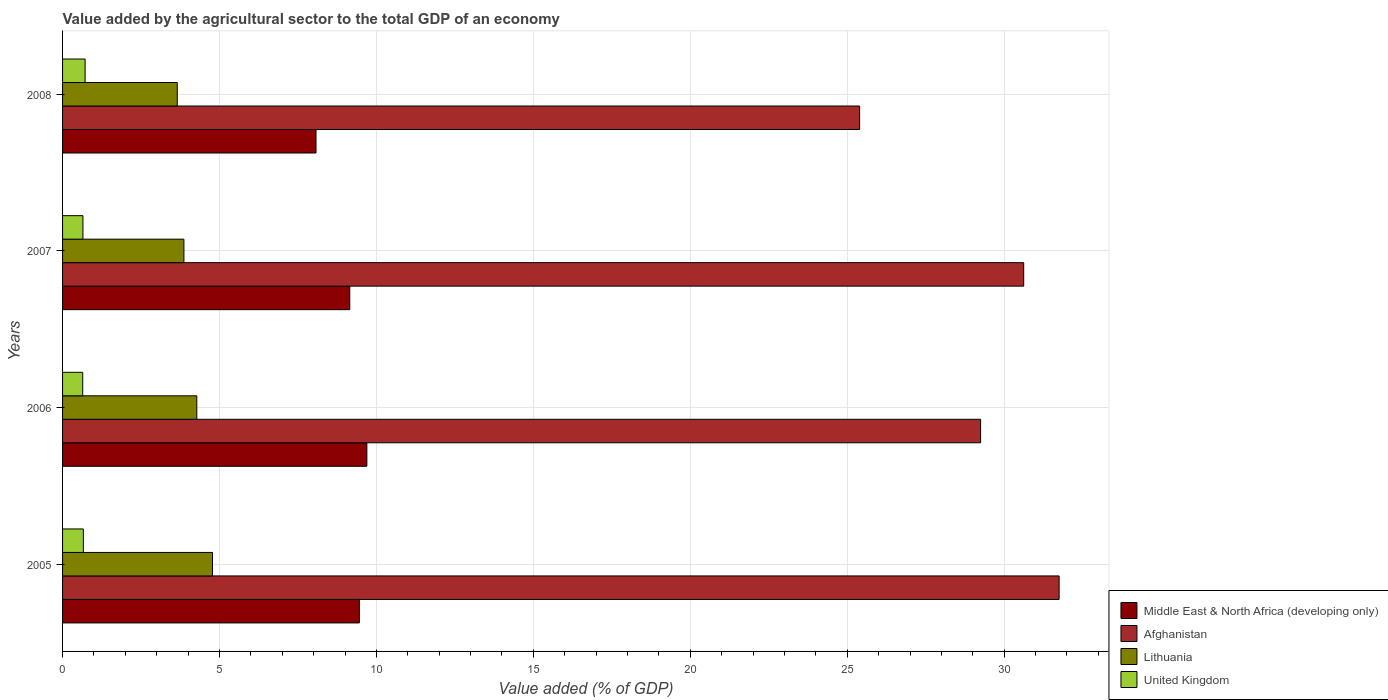How many different coloured bars are there?
Your response must be concise. 4. Are the number of bars on each tick of the Y-axis equal?
Keep it short and to the point. Yes. How many bars are there on the 4th tick from the top?
Give a very brief answer. 4. How many bars are there on the 1st tick from the bottom?
Your answer should be compact. 4. In how many cases, is the number of bars for a given year not equal to the number of legend labels?
Your answer should be very brief. 0. What is the value added by the agricultural sector to the total GDP in United Kingdom in 2005?
Your answer should be compact. 0.66. Across all years, what is the maximum value added by the agricultural sector to the total GDP in Lithuania?
Provide a succinct answer. 4.78. Across all years, what is the minimum value added by the agricultural sector to the total GDP in Lithuania?
Provide a succinct answer. 3.65. In which year was the value added by the agricultural sector to the total GDP in Middle East & North Africa (developing only) minimum?
Keep it short and to the point. 2008. What is the total value added by the agricultural sector to the total GDP in Afghanistan in the graph?
Your response must be concise. 117.02. What is the difference between the value added by the agricultural sector to the total GDP in Lithuania in 2005 and that in 2008?
Ensure brevity in your answer.  1.12. What is the difference between the value added by the agricultural sector to the total GDP in United Kingdom in 2006 and the value added by the agricultural sector to the total GDP in Afghanistan in 2005?
Keep it short and to the point. -31.11. What is the average value added by the agricultural sector to the total GDP in United Kingdom per year?
Provide a short and direct response. 0.67. In the year 2007, what is the difference between the value added by the agricultural sector to the total GDP in Afghanistan and value added by the agricultural sector to the total GDP in Middle East & North Africa (developing only)?
Keep it short and to the point. 21.47. What is the ratio of the value added by the agricultural sector to the total GDP in Middle East & North Africa (developing only) in 2007 to that in 2008?
Provide a succinct answer. 1.13. Is the difference between the value added by the agricultural sector to the total GDP in Afghanistan in 2006 and 2007 greater than the difference between the value added by the agricultural sector to the total GDP in Middle East & North Africa (developing only) in 2006 and 2007?
Your answer should be very brief. No. What is the difference between the highest and the second highest value added by the agricultural sector to the total GDP in Middle East & North Africa (developing only)?
Provide a succinct answer. 0.24. What is the difference between the highest and the lowest value added by the agricultural sector to the total GDP in United Kingdom?
Provide a short and direct response. 0.08. In how many years, is the value added by the agricultural sector to the total GDP in Middle East & North Africa (developing only) greater than the average value added by the agricultural sector to the total GDP in Middle East & North Africa (developing only) taken over all years?
Provide a short and direct response. 3. Is the sum of the value added by the agricultural sector to the total GDP in Lithuania in 2005 and 2008 greater than the maximum value added by the agricultural sector to the total GDP in United Kingdom across all years?
Keep it short and to the point. Yes. Is it the case that in every year, the sum of the value added by the agricultural sector to the total GDP in Afghanistan and value added by the agricultural sector to the total GDP in Lithuania is greater than the sum of value added by the agricultural sector to the total GDP in United Kingdom and value added by the agricultural sector to the total GDP in Middle East & North Africa (developing only)?
Ensure brevity in your answer.  Yes. What does the 4th bar from the top in 2007 represents?
Offer a terse response. Middle East & North Africa (developing only). What does the 3rd bar from the bottom in 2007 represents?
Your answer should be very brief. Lithuania. Is it the case that in every year, the sum of the value added by the agricultural sector to the total GDP in United Kingdom and value added by the agricultural sector to the total GDP in Lithuania is greater than the value added by the agricultural sector to the total GDP in Afghanistan?
Provide a succinct answer. No. How many bars are there?
Your response must be concise. 16. Are all the bars in the graph horizontal?
Give a very brief answer. Yes. How many years are there in the graph?
Your answer should be compact. 4. What is the difference between two consecutive major ticks on the X-axis?
Keep it short and to the point. 5. Are the values on the major ticks of X-axis written in scientific E-notation?
Your answer should be compact. No. Does the graph contain grids?
Offer a terse response. Yes. How are the legend labels stacked?
Your answer should be very brief. Vertical. What is the title of the graph?
Offer a terse response. Value added by the agricultural sector to the total GDP of an economy. What is the label or title of the X-axis?
Provide a short and direct response. Value added (% of GDP). What is the Value added (% of GDP) in Middle East & North Africa (developing only) in 2005?
Offer a very short reply. 9.46. What is the Value added (% of GDP) of Afghanistan in 2005?
Your response must be concise. 31.75. What is the Value added (% of GDP) in Lithuania in 2005?
Offer a very short reply. 4.78. What is the Value added (% of GDP) of United Kingdom in 2005?
Make the answer very short. 0.66. What is the Value added (% of GDP) of Middle East & North Africa (developing only) in 2006?
Your answer should be very brief. 9.7. What is the Value added (% of GDP) of Afghanistan in 2006?
Ensure brevity in your answer.  29.25. What is the Value added (% of GDP) of Lithuania in 2006?
Your answer should be very brief. 4.28. What is the Value added (% of GDP) of United Kingdom in 2006?
Provide a succinct answer. 0.64. What is the Value added (% of GDP) in Middle East & North Africa (developing only) in 2007?
Ensure brevity in your answer.  9.15. What is the Value added (% of GDP) of Afghanistan in 2007?
Ensure brevity in your answer.  30.62. What is the Value added (% of GDP) in Lithuania in 2007?
Keep it short and to the point. 3.87. What is the Value added (% of GDP) of United Kingdom in 2007?
Make the answer very short. 0.65. What is the Value added (% of GDP) in Middle East & North Africa (developing only) in 2008?
Give a very brief answer. 8.08. What is the Value added (% of GDP) in Afghanistan in 2008?
Offer a very short reply. 25.39. What is the Value added (% of GDP) in Lithuania in 2008?
Give a very brief answer. 3.65. What is the Value added (% of GDP) in United Kingdom in 2008?
Provide a short and direct response. 0.72. Across all years, what is the maximum Value added (% of GDP) of Middle East & North Africa (developing only)?
Offer a very short reply. 9.7. Across all years, what is the maximum Value added (% of GDP) of Afghanistan?
Provide a short and direct response. 31.75. Across all years, what is the maximum Value added (% of GDP) in Lithuania?
Give a very brief answer. 4.78. Across all years, what is the maximum Value added (% of GDP) in United Kingdom?
Keep it short and to the point. 0.72. Across all years, what is the minimum Value added (% of GDP) in Middle East & North Africa (developing only)?
Your answer should be compact. 8.08. Across all years, what is the minimum Value added (% of GDP) in Afghanistan?
Offer a terse response. 25.39. Across all years, what is the minimum Value added (% of GDP) of Lithuania?
Provide a succinct answer. 3.65. Across all years, what is the minimum Value added (% of GDP) in United Kingdom?
Your answer should be very brief. 0.64. What is the total Value added (% of GDP) in Middle East & North Africa (developing only) in the graph?
Your answer should be very brief. 36.38. What is the total Value added (% of GDP) of Afghanistan in the graph?
Your answer should be very brief. 117.02. What is the total Value added (% of GDP) in Lithuania in the graph?
Offer a very short reply. 16.57. What is the total Value added (% of GDP) of United Kingdom in the graph?
Provide a short and direct response. 2.67. What is the difference between the Value added (% of GDP) of Middle East & North Africa (developing only) in 2005 and that in 2006?
Keep it short and to the point. -0.24. What is the difference between the Value added (% of GDP) in Afghanistan in 2005 and that in 2006?
Your response must be concise. 2.5. What is the difference between the Value added (% of GDP) of Lithuania in 2005 and that in 2006?
Your answer should be compact. 0.5. What is the difference between the Value added (% of GDP) of United Kingdom in 2005 and that in 2006?
Offer a terse response. 0.02. What is the difference between the Value added (% of GDP) of Middle East & North Africa (developing only) in 2005 and that in 2007?
Your response must be concise. 0.3. What is the difference between the Value added (% of GDP) of Afghanistan in 2005 and that in 2007?
Offer a very short reply. 1.13. What is the difference between the Value added (% of GDP) in Lithuania in 2005 and that in 2007?
Provide a short and direct response. 0.91. What is the difference between the Value added (% of GDP) in United Kingdom in 2005 and that in 2007?
Your response must be concise. 0.01. What is the difference between the Value added (% of GDP) of Middle East & North Africa (developing only) in 2005 and that in 2008?
Provide a succinct answer. 1.38. What is the difference between the Value added (% of GDP) in Afghanistan in 2005 and that in 2008?
Provide a short and direct response. 6.36. What is the difference between the Value added (% of GDP) in Lithuania in 2005 and that in 2008?
Provide a short and direct response. 1.12. What is the difference between the Value added (% of GDP) of United Kingdom in 2005 and that in 2008?
Offer a very short reply. -0.06. What is the difference between the Value added (% of GDP) of Middle East & North Africa (developing only) in 2006 and that in 2007?
Provide a short and direct response. 0.54. What is the difference between the Value added (% of GDP) of Afghanistan in 2006 and that in 2007?
Provide a short and direct response. -1.37. What is the difference between the Value added (% of GDP) in Lithuania in 2006 and that in 2007?
Offer a terse response. 0.41. What is the difference between the Value added (% of GDP) of United Kingdom in 2006 and that in 2007?
Keep it short and to the point. -0.01. What is the difference between the Value added (% of GDP) of Middle East & North Africa (developing only) in 2006 and that in 2008?
Ensure brevity in your answer.  1.62. What is the difference between the Value added (% of GDP) in Afghanistan in 2006 and that in 2008?
Your answer should be compact. 3.85. What is the difference between the Value added (% of GDP) of Lithuania in 2006 and that in 2008?
Your answer should be compact. 0.62. What is the difference between the Value added (% of GDP) of United Kingdom in 2006 and that in 2008?
Provide a succinct answer. -0.08. What is the difference between the Value added (% of GDP) of Middle East & North Africa (developing only) in 2007 and that in 2008?
Offer a very short reply. 1.08. What is the difference between the Value added (% of GDP) of Afghanistan in 2007 and that in 2008?
Your answer should be very brief. 5.23. What is the difference between the Value added (% of GDP) in Lithuania in 2007 and that in 2008?
Your answer should be very brief. 0.21. What is the difference between the Value added (% of GDP) of United Kingdom in 2007 and that in 2008?
Your answer should be very brief. -0.07. What is the difference between the Value added (% of GDP) of Middle East & North Africa (developing only) in 2005 and the Value added (% of GDP) of Afghanistan in 2006?
Provide a short and direct response. -19.79. What is the difference between the Value added (% of GDP) in Middle East & North Africa (developing only) in 2005 and the Value added (% of GDP) in Lithuania in 2006?
Your answer should be compact. 5.18. What is the difference between the Value added (% of GDP) in Middle East & North Africa (developing only) in 2005 and the Value added (% of GDP) in United Kingdom in 2006?
Your response must be concise. 8.81. What is the difference between the Value added (% of GDP) in Afghanistan in 2005 and the Value added (% of GDP) in Lithuania in 2006?
Give a very brief answer. 27.47. What is the difference between the Value added (% of GDP) in Afghanistan in 2005 and the Value added (% of GDP) in United Kingdom in 2006?
Your response must be concise. 31.11. What is the difference between the Value added (% of GDP) in Lithuania in 2005 and the Value added (% of GDP) in United Kingdom in 2006?
Make the answer very short. 4.14. What is the difference between the Value added (% of GDP) of Middle East & North Africa (developing only) in 2005 and the Value added (% of GDP) of Afghanistan in 2007?
Offer a very short reply. -21.17. What is the difference between the Value added (% of GDP) in Middle East & North Africa (developing only) in 2005 and the Value added (% of GDP) in Lithuania in 2007?
Your answer should be very brief. 5.59. What is the difference between the Value added (% of GDP) of Middle East & North Africa (developing only) in 2005 and the Value added (% of GDP) of United Kingdom in 2007?
Make the answer very short. 8.81. What is the difference between the Value added (% of GDP) in Afghanistan in 2005 and the Value added (% of GDP) in Lithuania in 2007?
Keep it short and to the point. 27.88. What is the difference between the Value added (% of GDP) of Afghanistan in 2005 and the Value added (% of GDP) of United Kingdom in 2007?
Offer a terse response. 31.1. What is the difference between the Value added (% of GDP) of Lithuania in 2005 and the Value added (% of GDP) of United Kingdom in 2007?
Your answer should be compact. 4.13. What is the difference between the Value added (% of GDP) of Middle East & North Africa (developing only) in 2005 and the Value added (% of GDP) of Afghanistan in 2008?
Your answer should be very brief. -15.94. What is the difference between the Value added (% of GDP) of Middle East & North Africa (developing only) in 2005 and the Value added (% of GDP) of Lithuania in 2008?
Give a very brief answer. 5.8. What is the difference between the Value added (% of GDP) in Middle East & North Africa (developing only) in 2005 and the Value added (% of GDP) in United Kingdom in 2008?
Ensure brevity in your answer.  8.74. What is the difference between the Value added (% of GDP) in Afghanistan in 2005 and the Value added (% of GDP) in Lithuania in 2008?
Offer a very short reply. 28.1. What is the difference between the Value added (% of GDP) in Afghanistan in 2005 and the Value added (% of GDP) in United Kingdom in 2008?
Provide a short and direct response. 31.03. What is the difference between the Value added (% of GDP) in Lithuania in 2005 and the Value added (% of GDP) in United Kingdom in 2008?
Keep it short and to the point. 4.06. What is the difference between the Value added (% of GDP) in Middle East & North Africa (developing only) in 2006 and the Value added (% of GDP) in Afghanistan in 2007?
Make the answer very short. -20.93. What is the difference between the Value added (% of GDP) of Middle East & North Africa (developing only) in 2006 and the Value added (% of GDP) of Lithuania in 2007?
Provide a short and direct response. 5.83. What is the difference between the Value added (% of GDP) of Middle East & North Africa (developing only) in 2006 and the Value added (% of GDP) of United Kingdom in 2007?
Offer a very short reply. 9.05. What is the difference between the Value added (% of GDP) in Afghanistan in 2006 and the Value added (% of GDP) in Lithuania in 2007?
Your response must be concise. 25.38. What is the difference between the Value added (% of GDP) of Afghanistan in 2006 and the Value added (% of GDP) of United Kingdom in 2007?
Your response must be concise. 28.6. What is the difference between the Value added (% of GDP) in Lithuania in 2006 and the Value added (% of GDP) in United Kingdom in 2007?
Offer a terse response. 3.63. What is the difference between the Value added (% of GDP) in Middle East & North Africa (developing only) in 2006 and the Value added (% of GDP) in Afghanistan in 2008?
Ensure brevity in your answer.  -15.7. What is the difference between the Value added (% of GDP) of Middle East & North Africa (developing only) in 2006 and the Value added (% of GDP) of Lithuania in 2008?
Your answer should be very brief. 6.04. What is the difference between the Value added (% of GDP) in Middle East & North Africa (developing only) in 2006 and the Value added (% of GDP) in United Kingdom in 2008?
Your response must be concise. 8.98. What is the difference between the Value added (% of GDP) of Afghanistan in 2006 and the Value added (% of GDP) of Lithuania in 2008?
Your answer should be very brief. 25.6. What is the difference between the Value added (% of GDP) in Afghanistan in 2006 and the Value added (% of GDP) in United Kingdom in 2008?
Make the answer very short. 28.53. What is the difference between the Value added (% of GDP) of Lithuania in 2006 and the Value added (% of GDP) of United Kingdom in 2008?
Give a very brief answer. 3.56. What is the difference between the Value added (% of GDP) of Middle East & North Africa (developing only) in 2007 and the Value added (% of GDP) of Afghanistan in 2008?
Your answer should be very brief. -16.24. What is the difference between the Value added (% of GDP) of Middle East & North Africa (developing only) in 2007 and the Value added (% of GDP) of Lithuania in 2008?
Provide a short and direct response. 5.5. What is the difference between the Value added (% of GDP) of Middle East & North Africa (developing only) in 2007 and the Value added (% of GDP) of United Kingdom in 2008?
Ensure brevity in your answer.  8.43. What is the difference between the Value added (% of GDP) in Afghanistan in 2007 and the Value added (% of GDP) in Lithuania in 2008?
Offer a terse response. 26.97. What is the difference between the Value added (% of GDP) of Afghanistan in 2007 and the Value added (% of GDP) of United Kingdom in 2008?
Your response must be concise. 29.9. What is the difference between the Value added (% of GDP) in Lithuania in 2007 and the Value added (% of GDP) in United Kingdom in 2008?
Offer a very short reply. 3.15. What is the average Value added (% of GDP) of Middle East & North Africa (developing only) per year?
Keep it short and to the point. 9.09. What is the average Value added (% of GDP) of Afghanistan per year?
Your response must be concise. 29.25. What is the average Value added (% of GDP) of Lithuania per year?
Offer a very short reply. 4.14. What is the average Value added (% of GDP) in United Kingdom per year?
Your answer should be very brief. 0.67. In the year 2005, what is the difference between the Value added (% of GDP) of Middle East & North Africa (developing only) and Value added (% of GDP) of Afghanistan?
Offer a terse response. -22.3. In the year 2005, what is the difference between the Value added (% of GDP) in Middle East & North Africa (developing only) and Value added (% of GDP) in Lithuania?
Make the answer very short. 4.68. In the year 2005, what is the difference between the Value added (% of GDP) in Middle East & North Africa (developing only) and Value added (% of GDP) in United Kingdom?
Ensure brevity in your answer.  8.79. In the year 2005, what is the difference between the Value added (% of GDP) in Afghanistan and Value added (% of GDP) in Lithuania?
Your answer should be very brief. 26.97. In the year 2005, what is the difference between the Value added (% of GDP) of Afghanistan and Value added (% of GDP) of United Kingdom?
Offer a very short reply. 31.09. In the year 2005, what is the difference between the Value added (% of GDP) of Lithuania and Value added (% of GDP) of United Kingdom?
Your response must be concise. 4.11. In the year 2006, what is the difference between the Value added (% of GDP) in Middle East & North Africa (developing only) and Value added (% of GDP) in Afghanistan?
Offer a very short reply. -19.55. In the year 2006, what is the difference between the Value added (% of GDP) of Middle East & North Africa (developing only) and Value added (% of GDP) of Lithuania?
Offer a very short reply. 5.42. In the year 2006, what is the difference between the Value added (% of GDP) in Middle East & North Africa (developing only) and Value added (% of GDP) in United Kingdom?
Your answer should be very brief. 9.05. In the year 2006, what is the difference between the Value added (% of GDP) of Afghanistan and Value added (% of GDP) of Lithuania?
Provide a short and direct response. 24.97. In the year 2006, what is the difference between the Value added (% of GDP) in Afghanistan and Value added (% of GDP) in United Kingdom?
Offer a very short reply. 28.61. In the year 2006, what is the difference between the Value added (% of GDP) in Lithuania and Value added (% of GDP) in United Kingdom?
Keep it short and to the point. 3.63. In the year 2007, what is the difference between the Value added (% of GDP) of Middle East & North Africa (developing only) and Value added (% of GDP) of Afghanistan?
Your response must be concise. -21.47. In the year 2007, what is the difference between the Value added (% of GDP) in Middle East & North Africa (developing only) and Value added (% of GDP) in Lithuania?
Your answer should be very brief. 5.28. In the year 2007, what is the difference between the Value added (% of GDP) in Middle East & North Africa (developing only) and Value added (% of GDP) in United Kingdom?
Provide a short and direct response. 8.5. In the year 2007, what is the difference between the Value added (% of GDP) of Afghanistan and Value added (% of GDP) of Lithuania?
Provide a short and direct response. 26.76. In the year 2007, what is the difference between the Value added (% of GDP) of Afghanistan and Value added (% of GDP) of United Kingdom?
Make the answer very short. 29.97. In the year 2007, what is the difference between the Value added (% of GDP) in Lithuania and Value added (% of GDP) in United Kingdom?
Provide a succinct answer. 3.22. In the year 2008, what is the difference between the Value added (% of GDP) of Middle East & North Africa (developing only) and Value added (% of GDP) of Afghanistan?
Provide a short and direct response. -17.32. In the year 2008, what is the difference between the Value added (% of GDP) in Middle East & North Africa (developing only) and Value added (% of GDP) in Lithuania?
Your answer should be compact. 4.42. In the year 2008, what is the difference between the Value added (% of GDP) of Middle East & North Africa (developing only) and Value added (% of GDP) of United Kingdom?
Provide a succinct answer. 7.36. In the year 2008, what is the difference between the Value added (% of GDP) of Afghanistan and Value added (% of GDP) of Lithuania?
Your answer should be very brief. 21.74. In the year 2008, what is the difference between the Value added (% of GDP) of Afghanistan and Value added (% of GDP) of United Kingdom?
Your answer should be compact. 24.68. In the year 2008, what is the difference between the Value added (% of GDP) in Lithuania and Value added (% of GDP) in United Kingdom?
Your answer should be compact. 2.94. What is the ratio of the Value added (% of GDP) of Middle East & North Africa (developing only) in 2005 to that in 2006?
Ensure brevity in your answer.  0.98. What is the ratio of the Value added (% of GDP) in Afghanistan in 2005 to that in 2006?
Make the answer very short. 1.09. What is the ratio of the Value added (% of GDP) of Lithuania in 2005 to that in 2006?
Your answer should be very brief. 1.12. What is the ratio of the Value added (% of GDP) in United Kingdom in 2005 to that in 2006?
Give a very brief answer. 1.03. What is the ratio of the Value added (% of GDP) of Afghanistan in 2005 to that in 2007?
Offer a terse response. 1.04. What is the ratio of the Value added (% of GDP) in Lithuania in 2005 to that in 2007?
Keep it short and to the point. 1.24. What is the ratio of the Value added (% of GDP) of United Kingdom in 2005 to that in 2007?
Ensure brevity in your answer.  1.02. What is the ratio of the Value added (% of GDP) of Middle East & North Africa (developing only) in 2005 to that in 2008?
Offer a terse response. 1.17. What is the ratio of the Value added (% of GDP) in Afghanistan in 2005 to that in 2008?
Provide a short and direct response. 1.25. What is the ratio of the Value added (% of GDP) in Lithuania in 2005 to that in 2008?
Provide a succinct answer. 1.31. What is the ratio of the Value added (% of GDP) in United Kingdom in 2005 to that in 2008?
Keep it short and to the point. 0.92. What is the ratio of the Value added (% of GDP) in Middle East & North Africa (developing only) in 2006 to that in 2007?
Keep it short and to the point. 1.06. What is the ratio of the Value added (% of GDP) of Afghanistan in 2006 to that in 2007?
Make the answer very short. 0.96. What is the ratio of the Value added (% of GDP) of Lithuania in 2006 to that in 2007?
Ensure brevity in your answer.  1.11. What is the ratio of the Value added (% of GDP) in United Kingdom in 2006 to that in 2007?
Your answer should be very brief. 0.99. What is the ratio of the Value added (% of GDP) of Middle East & North Africa (developing only) in 2006 to that in 2008?
Your answer should be compact. 1.2. What is the ratio of the Value added (% of GDP) of Afghanistan in 2006 to that in 2008?
Offer a terse response. 1.15. What is the ratio of the Value added (% of GDP) of Lithuania in 2006 to that in 2008?
Ensure brevity in your answer.  1.17. What is the ratio of the Value added (% of GDP) in United Kingdom in 2006 to that in 2008?
Give a very brief answer. 0.89. What is the ratio of the Value added (% of GDP) in Middle East & North Africa (developing only) in 2007 to that in 2008?
Keep it short and to the point. 1.13. What is the ratio of the Value added (% of GDP) of Afghanistan in 2007 to that in 2008?
Provide a short and direct response. 1.21. What is the ratio of the Value added (% of GDP) of Lithuania in 2007 to that in 2008?
Provide a short and direct response. 1.06. What is the ratio of the Value added (% of GDP) in United Kingdom in 2007 to that in 2008?
Keep it short and to the point. 0.9. What is the difference between the highest and the second highest Value added (% of GDP) in Middle East & North Africa (developing only)?
Your answer should be compact. 0.24. What is the difference between the highest and the second highest Value added (% of GDP) in Afghanistan?
Make the answer very short. 1.13. What is the difference between the highest and the second highest Value added (% of GDP) in Lithuania?
Keep it short and to the point. 0.5. What is the difference between the highest and the second highest Value added (% of GDP) in United Kingdom?
Provide a succinct answer. 0.06. What is the difference between the highest and the lowest Value added (% of GDP) in Middle East & North Africa (developing only)?
Make the answer very short. 1.62. What is the difference between the highest and the lowest Value added (% of GDP) in Afghanistan?
Offer a very short reply. 6.36. What is the difference between the highest and the lowest Value added (% of GDP) in Lithuania?
Offer a terse response. 1.12. What is the difference between the highest and the lowest Value added (% of GDP) of United Kingdom?
Keep it short and to the point. 0.08. 